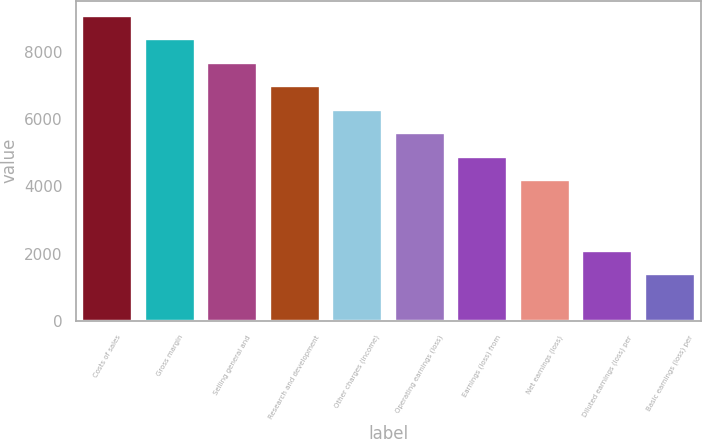Convert chart to OTSL. <chart><loc_0><loc_0><loc_500><loc_500><bar_chart><fcel>Costs of sales<fcel>Gross margin<fcel>Selling general and<fcel>Research and development<fcel>Other charges (income)<fcel>Operating earnings (loss)<fcel>Earnings (loss) from<fcel>Net earnings (loss)<fcel>Diluted earnings (loss) per<fcel>Basic earnings (loss) per<nl><fcel>9072.68<fcel>8374.78<fcel>7676.89<fcel>6978.99<fcel>6281.09<fcel>5583.2<fcel>4885.31<fcel>4187.41<fcel>2093.73<fcel>1395.84<nl></chart> 